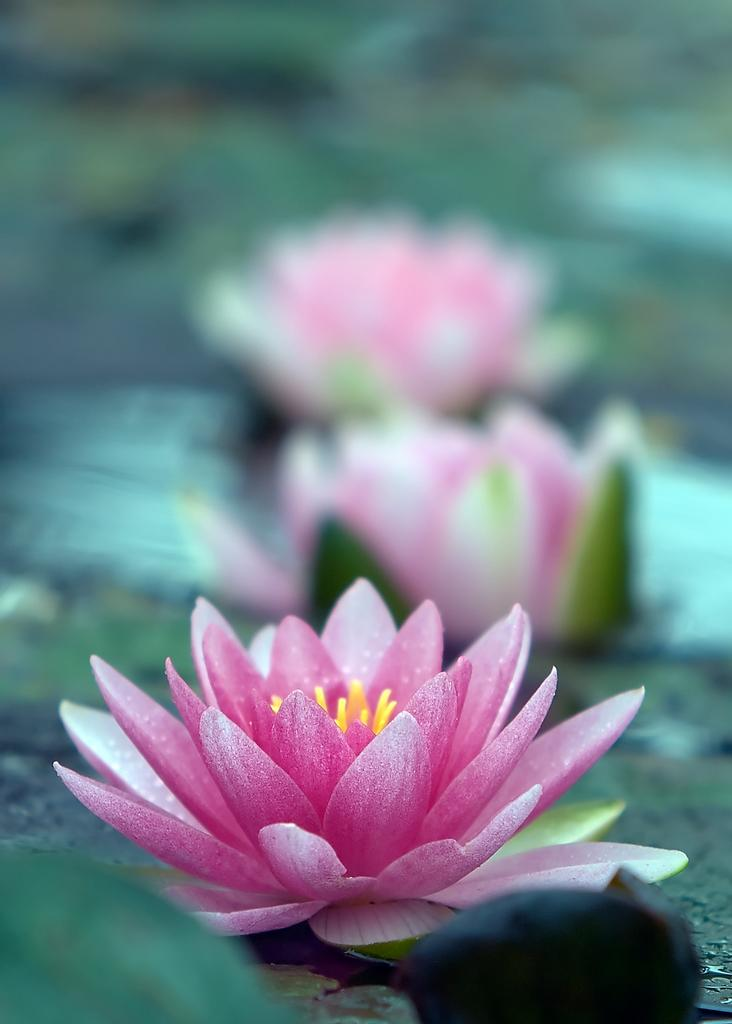What is the main subject in the center of the image? There are flowers in the center of the image. What type of train can be seen on top of the flowers in the image? There is no train present in the image, as it features only flowers in the center. 